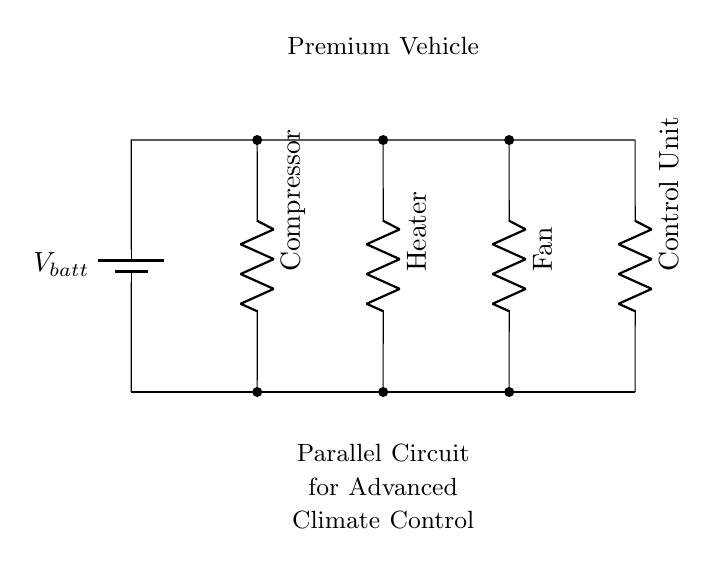What type of circuit is depicted here? The circuit diagram shows a parallel configuration, which is indicated by the branches that split from a common voltage source and connect multiple components independently.
Answer: Parallel How many components are connected in parallel? There are four components connected in parallel, each represented by a resistor (the compressor, heater, fan, and control unit) connected to the same voltage source.
Answer: Four What is the function of the control unit in this circuit? The control unit regulates the overall operation of the climate control system, controlling how the other components (compressor, heater, fan) function to maintain desired climate conditions in the vehicle.
Answer: Regulation What is the potential difference across each component? Each component experiences the same voltage equal to the battery voltage, as they are connected in parallel and hence share the same voltage level.
Answer: Battery voltage Which component would be the last to fail if power is reduced? The fan would be the last to fail since it generally has a lower power requirement compared to the compressor and heater, making it more resistant to lower voltages.
Answer: Fan What happens to the total current if one component fails? If one component fails, the total current flowing through the circuit would decrease slightly, but the rest of the components would continue to operate as the circuit is still a parallel connection.
Answer: Decreases 